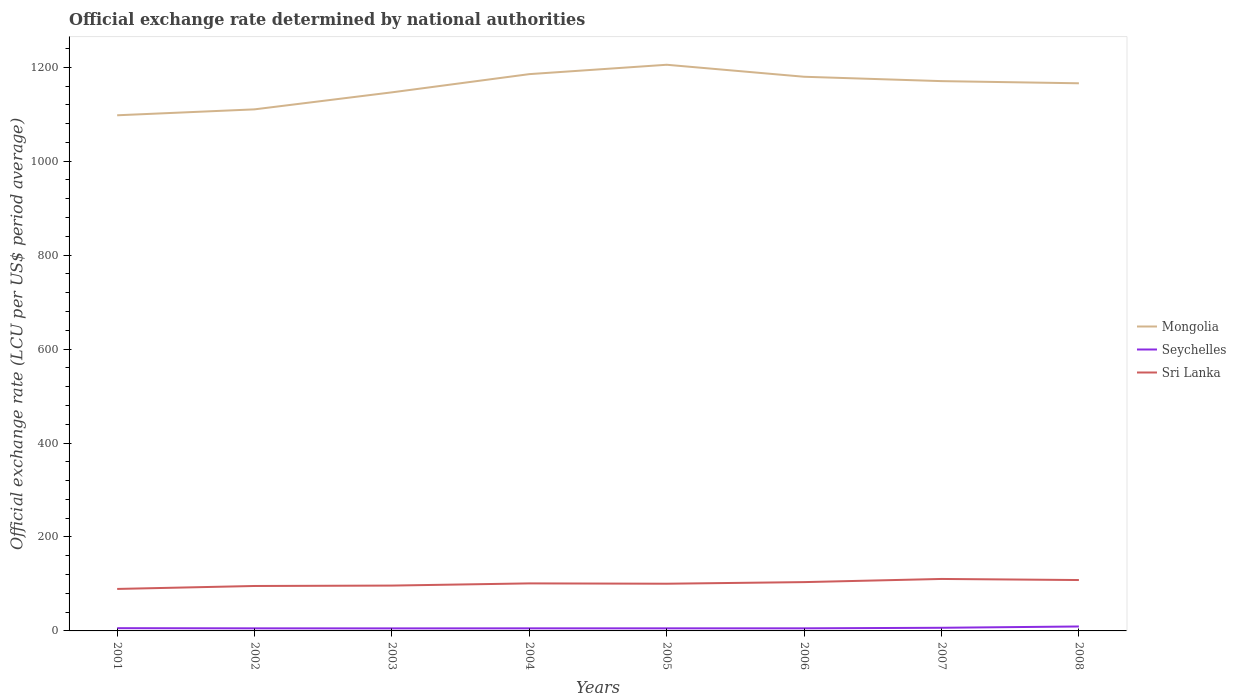How many different coloured lines are there?
Give a very brief answer. 3. Across all years, what is the maximum official exchange rate in Seychelles?
Offer a very short reply. 5.4. In which year was the official exchange rate in Seychelles maximum?
Keep it short and to the point. 2003. What is the total official exchange rate in Seychelles in the graph?
Ensure brevity in your answer.  0.38. What is the difference between the highest and the second highest official exchange rate in Mongolia?
Provide a short and direct response. 107.55. Is the official exchange rate in Seychelles strictly greater than the official exchange rate in Mongolia over the years?
Give a very brief answer. Yes. What is the difference between two consecutive major ticks on the Y-axis?
Provide a succinct answer. 200. Are the values on the major ticks of Y-axis written in scientific E-notation?
Keep it short and to the point. No. Does the graph contain grids?
Your response must be concise. No. Where does the legend appear in the graph?
Your answer should be very brief. Center right. What is the title of the graph?
Offer a very short reply. Official exchange rate determined by national authorities. What is the label or title of the X-axis?
Your response must be concise. Years. What is the label or title of the Y-axis?
Offer a very short reply. Official exchange rate (LCU per US$ period average). What is the Official exchange rate (LCU per US$ period average) of Mongolia in 2001?
Give a very brief answer. 1097.7. What is the Official exchange rate (LCU per US$ period average) of Seychelles in 2001?
Provide a short and direct response. 5.86. What is the Official exchange rate (LCU per US$ period average) in Sri Lanka in 2001?
Keep it short and to the point. 89.38. What is the Official exchange rate (LCU per US$ period average) in Mongolia in 2002?
Your response must be concise. 1110.31. What is the Official exchange rate (LCU per US$ period average) in Seychelles in 2002?
Provide a succinct answer. 5.48. What is the Official exchange rate (LCU per US$ period average) in Sri Lanka in 2002?
Provide a short and direct response. 95.66. What is the Official exchange rate (LCU per US$ period average) of Mongolia in 2003?
Offer a terse response. 1146.54. What is the Official exchange rate (LCU per US$ period average) of Seychelles in 2003?
Your response must be concise. 5.4. What is the Official exchange rate (LCU per US$ period average) in Sri Lanka in 2003?
Offer a terse response. 96.52. What is the Official exchange rate (LCU per US$ period average) of Mongolia in 2004?
Provide a succinct answer. 1185.3. What is the Official exchange rate (LCU per US$ period average) of Sri Lanka in 2004?
Provide a short and direct response. 101.19. What is the Official exchange rate (LCU per US$ period average) in Mongolia in 2005?
Your response must be concise. 1205.25. What is the Official exchange rate (LCU per US$ period average) of Sri Lanka in 2005?
Ensure brevity in your answer.  100.5. What is the Official exchange rate (LCU per US$ period average) in Mongolia in 2006?
Your answer should be very brief. 1179.7. What is the Official exchange rate (LCU per US$ period average) in Seychelles in 2006?
Offer a very short reply. 5.52. What is the Official exchange rate (LCU per US$ period average) in Sri Lanka in 2006?
Make the answer very short. 103.91. What is the Official exchange rate (LCU per US$ period average) of Mongolia in 2007?
Provide a short and direct response. 1170.4. What is the Official exchange rate (LCU per US$ period average) in Seychelles in 2007?
Keep it short and to the point. 6.7. What is the Official exchange rate (LCU per US$ period average) of Sri Lanka in 2007?
Offer a terse response. 110.62. What is the Official exchange rate (LCU per US$ period average) of Mongolia in 2008?
Offer a very short reply. 1165.8. What is the Official exchange rate (LCU per US$ period average) of Seychelles in 2008?
Your answer should be very brief. 9.46. What is the Official exchange rate (LCU per US$ period average) of Sri Lanka in 2008?
Make the answer very short. 108.33. Across all years, what is the maximum Official exchange rate (LCU per US$ period average) of Mongolia?
Ensure brevity in your answer.  1205.25. Across all years, what is the maximum Official exchange rate (LCU per US$ period average) of Seychelles?
Your answer should be compact. 9.46. Across all years, what is the maximum Official exchange rate (LCU per US$ period average) of Sri Lanka?
Give a very brief answer. 110.62. Across all years, what is the minimum Official exchange rate (LCU per US$ period average) in Mongolia?
Keep it short and to the point. 1097.7. Across all years, what is the minimum Official exchange rate (LCU per US$ period average) of Seychelles?
Provide a short and direct response. 5.4. Across all years, what is the minimum Official exchange rate (LCU per US$ period average) in Sri Lanka?
Your answer should be very brief. 89.38. What is the total Official exchange rate (LCU per US$ period average) in Mongolia in the graph?
Offer a very short reply. 9261. What is the total Official exchange rate (LCU per US$ period average) in Seychelles in the graph?
Your answer should be very brief. 49.42. What is the total Official exchange rate (LCU per US$ period average) of Sri Lanka in the graph?
Make the answer very short. 806.13. What is the difference between the Official exchange rate (LCU per US$ period average) in Mongolia in 2001 and that in 2002?
Keep it short and to the point. -12.61. What is the difference between the Official exchange rate (LCU per US$ period average) in Seychelles in 2001 and that in 2002?
Your response must be concise. 0.38. What is the difference between the Official exchange rate (LCU per US$ period average) in Sri Lanka in 2001 and that in 2002?
Provide a short and direct response. -6.28. What is the difference between the Official exchange rate (LCU per US$ period average) in Mongolia in 2001 and that in 2003?
Your answer should be very brief. -48.84. What is the difference between the Official exchange rate (LCU per US$ period average) in Seychelles in 2001 and that in 2003?
Offer a terse response. 0.46. What is the difference between the Official exchange rate (LCU per US$ period average) in Sri Lanka in 2001 and that in 2003?
Provide a short and direct response. -7.14. What is the difference between the Official exchange rate (LCU per US$ period average) of Mongolia in 2001 and that in 2004?
Provide a succinct answer. -87.6. What is the difference between the Official exchange rate (LCU per US$ period average) in Seychelles in 2001 and that in 2004?
Offer a terse response. 0.36. What is the difference between the Official exchange rate (LCU per US$ period average) in Sri Lanka in 2001 and that in 2004?
Offer a terse response. -11.81. What is the difference between the Official exchange rate (LCU per US$ period average) of Mongolia in 2001 and that in 2005?
Your answer should be very brief. -107.55. What is the difference between the Official exchange rate (LCU per US$ period average) in Seychelles in 2001 and that in 2005?
Ensure brevity in your answer.  0.36. What is the difference between the Official exchange rate (LCU per US$ period average) in Sri Lanka in 2001 and that in 2005?
Offer a very short reply. -11.12. What is the difference between the Official exchange rate (LCU per US$ period average) of Mongolia in 2001 and that in 2006?
Keep it short and to the point. -82. What is the difference between the Official exchange rate (LCU per US$ period average) of Seychelles in 2001 and that in 2006?
Offer a very short reply. 0.34. What is the difference between the Official exchange rate (LCU per US$ period average) in Sri Lanka in 2001 and that in 2006?
Offer a terse response. -14.53. What is the difference between the Official exchange rate (LCU per US$ period average) of Mongolia in 2001 and that in 2007?
Provide a succinct answer. -72.7. What is the difference between the Official exchange rate (LCU per US$ period average) in Seychelles in 2001 and that in 2007?
Your response must be concise. -0.84. What is the difference between the Official exchange rate (LCU per US$ period average) of Sri Lanka in 2001 and that in 2007?
Offer a terse response. -21.24. What is the difference between the Official exchange rate (LCU per US$ period average) of Mongolia in 2001 and that in 2008?
Ensure brevity in your answer.  -68.11. What is the difference between the Official exchange rate (LCU per US$ period average) in Seychelles in 2001 and that in 2008?
Offer a terse response. -3.6. What is the difference between the Official exchange rate (LCU per US$ period average) in Sri Lanka in 2001 and that in 2008?
Your response must be concise. -18.95. What is the difference between the Official exchange rate (LCU per US$ period average) of Mongolia in 2002 and that in 2003?
Provide a succinct answer. -36.23. What is the difference between the Official exchange rate (LCU per US$ period average) in Seychelles in 2002 and that in 2003?
Provide a succinct answer. 0.08. What is the difference between the Official exchange rate (LCU per US$ period average) in Sri Lanka in 2002 and that in 2003?
Ensure brevity in your answer.  -0.86. What is the difference between the Official exchange rate (LCU per US$ period average) of Mongolia in 2002 and that in 2004?
Offer a terse response. -74.99. What is the difference between the Official exchange rate (LCU per US$ period average) in Seychelles in 2002 and that in 2004?
Provide a succinct answer. -0.02. What is the difference between the Official exchange rate (LCU per US$ period average) of Sri Lanka in 2002 and that in 2004?
Your answer should be compact. -5.53. What is the difference between the Official exchange rate (LCU per US$ period average) in Mongolia in 2002 and that in 2005?
Ensure brevity in your answer.  -94.94. What is the difference between the Official exchange rate (LCU per US$ period average) in Seychelles in 2002 and that in 2005?
Offer a very short reply. -0.02. What is the difference between the Official exchange rate (LCU per US$ period average) of Sri Lanka in 2002 and that in 2005?
Offer a very short reply. -4.84. What is the difference between the Official exchange rate (LCU per US$ period average) in Mongolia in 2002 and that in 2006?
Your answer should be compact. -69.39. What is the difference between the Official exchange rate (LCU per US$ period average) of Seychelles in 2002 and that in 2006?
Ensure brevity in your answer.  -0.04. What is the difference between the Official exchange rate (LCU per US$ period average) of Sri Lanka in 2002 and that in 2006?
Keep it short and to the point. -8.25. What is the difference between the Official exchange rate (LCU per US$ period average) in Mongolia in 2002 and that in 2007?
Give a very brief answer. -60.09. What is the difference between the Official exchange rate (LCU per US$ period average) in Seychelles in 2002 and that in 2007?
Make the answer very short. -1.22. What is the difference between the Official exchange rate (LCU per US$ period average) in Sri Lanka in 2002 and that in 2007?
Give a very brief answer. -14.96. What is the difference between the Official exchange rate (LCU per US$ period average) of Mongolia in 2002 and that in 2008?
Provide a short and direct response. -55.49. What is the difference between the Official exchange rate (LCU per US$ period average) in Seychelles in 2002 and that in 2008?
Ensure brevity in your answer.  -3.98. What is the difference between the Official exchange rate (LCU per US$ period average) in Sri Lanka in 2002 and that in 2008?
Make the answer very short. -12.67. What is the difference between the Official exchange rate (LCU per US$ period average) of Mongolia in 2003 and that in 2004?
Your response must be concise. -38.76. What is the difference between the Official exchange rate (LCU per US$ period average) of Seychelles in 2003 and that in 2004?
Give a very brief answer. -0.1. What is the difference between the Official exchange rate (LCU per US$ period average) in Sri Lanka in 2003 and that in 2004?
Offer a very short reply. -4.67. What is the difference between the Official exchange rate (LCU per US$ period average) of Mongolia in 2003 and that in 2005?
Provide a short and direct response. -58.7. What is the difference between the Official exchange rate (LCU per US$ period average) of Seychelles in 2003 and that in 2005?
Your answer should be compact. -0.1. What is the difference between the Official exchange rate (LCU per US$ period average) in Sri Lanka in 2003 and that in 2005?
Your answer should be compact. -3.98. What is the difference between the Official exchange rate (LCU per US$ period average) in Mongolia in 2003 and that in 2006?
Make the answer very short. -33.16. What is the difference between the Official exchange rate (LCU per US$ period average) of Seychelles in 2003 and that in 2006?
Your response must be concise. -0.12. What is the difference between the Official exchange rate (LCU per US$ period average) of Sri Lanka in 2003 and that in 2006?
Your response must be concise. -7.39. What is the difference between the Official exchange rate (LCU per US$ period average) in Mongolia in 2003 and that in 2007?
Your response must be concise. -23.86. What is the difference between the Official exchange rate (LCU per US$ period average) of Seychelles in 2003 and that in 2007?
Your response must be concise. -1.3. What is the difference between the Official exchange rate (LCU per US$ period average) of Sri Lanka in 2003 and that in 2007?
Keep it short and to the point. -14.1. What is the difference between the Official exchange rate (LCU per US$ period average) in Mongolia in 2003 and that in 2008?
Offer a terse response. -19.26. What is the difference between the Official exchange rate (LCU per US$ period average) of Seychelles in 2003 and that in 2008?
Offer a terse response. -4.06. What is the difference between the Official exchange rate (LCU per US$ period average) of Sri Lanka in 2003 and that in 2008?
Offer a very short reply. -11.81. What is the difference between the Official exchange rate (LCU per US$ period average) of Mongolia in 2004 and that in 2005?
Offer a very short reply. -19.95. What is the difference between the Official exchange rate (LCU per US$ period average) of Seychelles in 2004 and that in 2005?
Provide a short and direct response. 0. What is the difference between the Official exchange rate (LCU per US$ period average) of Sri Lanka in 2004 and that in 2005?
Your response must be concise. 0.7. What is the difference between the Official exchange rate (LCU per US$ period average) of Mongolia in 2004 and that in 2006?
Provide a short and direct response. 5.6. What is the difference between the Official exchange rate (LCU per US$ period average) in Seychelles in 2004 and that in 2006?
Make the answer very short. -0.02. What is the difference between the Official exchange rate (LCU per US$ period average) of Sri Lanka in 2004 and that in 2006?
Your response must be concise. -2.72. What is the difference between the Official exchange rate (LCU per US$ period average) in Mongolia in 2004 and that in 2007?
Offer a terse response. 14.9. What is the difference between the Official exchange rate (LCU per US$ period average) of Seychelles in 2004 and that in 2007?
Ensure brevity in your answer.  -1.2. What is the difference between the Official exchange rate (LCU per US$ period average) of Sri Lanka in 2004 and that in 2007?
Make the answer very short. -9.43. What is the difference between the Official exchange rate (LCU per US$ period average) of Mongolia in 2004 and that in 2008?
Make the answer very short. 19.49. What is the difference between the Official exchange rate (LCU per US$ period average) in Seychelles in 2004 and that in 2008?
Offer a terse response. -3.96. What is the difference between the Official exchange rate (LCU per US$ period average) in Sri Lanka in 2004 and that in 2008?
Offer a terse response. -7.14. What is the difference between the Official exchange rate (LCU per US$ period average) of Mongolia in 2005 and that in 2006?
Make the answer very short. 25.55. What is the difference between the Official exchange rate (LCU per US$ period average) of Seychelles in 2005 and that in 2006?
Your response must be concise. -0.02. What is the difference between the Official exchange rate (LCU per US$ period average) of Sri Lanka in 2005 and that in 2006?
Keep it short and to the point. -3.42. What is the difference between the Official exchange rate (LCU per US$ period average) in Mongolia in 2005 and that in 2007?
Your answer should be compact. 34.85. What is the difference between the Official exchange rate (LCU per US$ period average) of Seychelles in 2005 and that in 2007?
Offer a very short reply. -1.2. What is the difference between the Official exchange rate (LCU per US$ period average) of Sri Lanka in 2005 and that in 2007?
Provide a short and direct response. -10.13. What is the difference between the Official exchange rate (LCU per US$ period average) of Mongolia in 2005 and that in 2008?
Offer a very short reply. 39.44. What is the difference between the Official exchange rate (LCU per US$ period average) of Seychelles in 2005 and that in 2008?
Provide a succinct answer. -3.96. What is the difference between the Official exchange rate (LCU per US$ period average) in Sri Lanka in 2005 and that in 2008?
Offer a terse response. -7.84. What is the difference between the Official exchange rate (LCU per US$ period average) in Mongolia in 2006 and that in 2007?
Give a very brief answer. 9.3. What is the difference between the Official exchange rate (LCU per US$ period average) of Seychelles in 2006 and that in 2007?
Your response must be concise. -1.18. What is the difference between the Official exchange rate (LCU per US$ period average) of Sri Lanka in 2006 and that in 2007?
Make the answer very short. -6.71. What is the difference between the Official exchange rate (LCU per US$ period average) of Mongolia in 2006 and that in 2008?
Provide a succinct answer. 13.89. What is the difference between the Official exchange rate (LCU per US$ period average) of Seychelles in 2006 and that in 2008?
Ensure brevity in your answer.  -3.94. What is the difference between the Official exchange rate (LCU per US$ period average) in Sri Lanka in 2006 and that in 2008?
Give a very brief answer. -4.42. What is the difference between the Official exchange rate (LCU per US$ period average) of Mongolia in 2007 and that in 2008?
Provide a short and direct response. 4.6. What is the difference between the Official exchange rate (LCU per US$ period average) of Seychelles in 2007 and that in 2008?
Give a very brief answer. -2.76. What is the difference between the Official exchange rate (LCU per US$ period average) of Sri Lanka in 2007 and that in 2008?
Give a very brief answer. 2.29. What is the difference between the Official exchange rate (LCU per US$ period average) in Mongolia in 2001 and the Official exchange rate (LCU per US$ period average) in Seychelles in 2002?
Make the answer very short. 1092.22. What is the difference between the Official exchange rate (LCU per US$ period average) in Mongolia in 2001 and the Official exchange rate (LCU per US$ period average) in Sri Lanka in 2002?
Your response must be concise. 1002.04. What is the difference between the Official exchange rate (LCU per US$ period average) in Seychelles in 2001 and the Official exchange rate (LCU per US$ period average) in Sri Lanka in 2002?
Your answer should be compact. -89.8. What is the difference between the Official exchange rate (LCU per US$ period average) of Mongolia in 2001 and the Official exchange rate (LCU per US$ period average) of Seychelles in 2003?
Offer a terse response. 1092.3. What is the difference between the Official exchange rate (LCU per US$ period average) of Mongolia in 2001 and the Official exchange rate (LCU per US$ period average) of Sri Lanka in 2003?
Offer a terse response. 1001.18. What is the difference between the Official exchange rate (LCU per US$ period average) in Seychelles in 2001 and the Official exchange rate (LCU per US$ period average) in Sri Lanka in 2003?
Provide a succinct answer. -90.66. What is the difference between the Official exchange rate (LCU per US$ period average) of Mongolia in 2001 and the Official exchange rate (LCU per US$ period average) of Seychelles in 2004?
Offer a terse response. 1092.2. What is the difference between the Official exchange rate (LCU per US$ period average) in Mongolia in 2001 and the Official exchange rate (LCU per US$ period average) in Sri Lanka in 2004?
Give a very brief answer. 996.5. What is the difference between the Official exchange rate (LCU per US$ period average) of Seychelles in 2001 and the Official exchange rate (LCU per US$ period average) of Sri Lanka in 2004?
Keep it short and to the point. -95.34. What is the difference between the Official exchange rate (LCU per US$ period average) of Mongolia in 2001 and the Official exchange rate (LCU per US$ period average) of Seychelles in 2005?
Your answer should be very brief. 1092.2. What is the difference between the Official exchange rate (LCU per US$ period average) of Mongolia in 2001 and the Official exchange rate (LCU per US$ period average) of Sri Lanka in 2005?
Offer a terse response. 997.2. What is the difference between the Official exchange rate (LCU per US$ period average) of Seychelles in 2001 and the Official exchange rate (LCU per US$ period average) of Sri Lanka in 2005?
Your answer should be very brief. -94.64. What is the difference between the Official exchange rate (LCU per US$ period average) of Mongolia in 2001 and the Official exchange rate (LCU per US$ period average) of Seychelles in 2006?
Give a very brief answer. 1092.18. What is the difference between the Official exchange rate (LCU per US$ period average) of Mongolia in 2001 and the Official exchange rate (LCU per US$ period average) of Sri Lanka in 2006?
Your answer should be very brief. 993.78. What is the difference between the Official exchange rate (LCU per US$ period average) of Seychelles in 2001 and the Official exchange rate (LCU per US$ period average) of Sri Lanka in 2006?
Ensure brevity in your answer.  -98.06. What is the difference between the Official exchange rate (LCU per US$ period average) in Mongolia in 2001 and the Official exchange rate (LCU per US$ period average) in Seychelles in 2007?
Provide a succinct answer. 1091. What is the difference between the Official exchange rate (LCU per US$ period average) in Mongolia in 2001 and the Official exchange rate (LCU per US$ period average) in Sri Lanka in 2007?
Provide a succinct answer. 987.07. What is the difference between the Official exchange rate (LCU per US$ period average) of Seychelles in 2001 and the Official exchange rate (LCU per US$ period average) of Sri Lanka in 2007?
Make the answer very short. -104.77. What is the difference between the Official exchange rate (LCU per US$ period average) of Mongolia in 2001 and the Official exchange rate (LCU per US$ period average) of Seychelles in 2008?
Ensure brevity in your answer.  1088.24. What is the difference between the Official exchange rate (LCU per US$ period average) of Mongolia in 2001 and the Official exchange rate (LCU per US$ period average) of Sri Lanka in 2008?
Offer a terse response. 989.36. What is the difference between the Official exchange rate (LCU per US$ period average) in Seychelles in 2001 and the Official exchange rate (LCU per US$ period average) in Sri Lanka in 2008?
Offer a terse response. -102.48. What is the difference between the Official exchange rate (LCU per US$ period average) in Mongolia in 2002 and the Official exchange rate (LCU per US$ period average) in Seychelles in 2003?
Offer a very short reply. 1104.91. What is the difference between the Official exchange rate (LCU per US$ period average) in Mongolia in 2002 and the Official exchange rate (LCU per US$ period average) in Sri Lanka in 2003?
Your answer should be compact. 1013.79. What is the difference between the Official exchange rate (LCU per US$ period average) of Seychelles in 2002 and the Official exchange rate (LCU per US$ period average) of Sri Lanka in 2003?
Provide a short and direct response. -91.04. What is the difference between the Official exchange rate (LCU per US$ period average) in Mongolia in 2002 and the Official exchange rate (LCU per US$ period average) in Seychelles in 2004?
Provide a succinct answer. 1104.81. What is the difference between the Official exchange rate (LCU per US$ period average) of Mongolia in 2002 and the Official exchange rate (LCU per US$ period average) of Sri Lanka in 2004?
Give a very brief answer. 1009.12. What is the difference between the Official exchange rate (LCU per US$ period average) in Seychelles in 2002 and the Official exchange rate (LCU per US$ period average) in Sri Lanka in 2004?
Your response must be concise. -95.71. What is the difference between the Official exchange rate (LCU per US$ period average) in Mongolia in 2002 and the Official exchange rate (LCU per US$ period average) in Seychelles in 2005?
Your response must be concise. 1104.81. What is the difference between the Official exchange rate (LCU per US$ period average) of Mongolia in 2002 and the Official exchange rate (LCU per US$ period average) of Sri Lanka in 2005?
Your answer should be very brief. 1009.81. What is the difference between the Official exchange rate (LCU per US$ period average) in Seychelles in 2002 and the Official exchange rate (LCU per US$ period average) in Sri Lanka in 2005?
Ensure brevity in your answer.  -95.02. What is the difference between the Official exchange rate (LCU per US$ period average) in Mongolia in 2002 and the Official exchange rate (LCU per US$ period average) in Seychelles in 2006?
Make the answer very short. 1104.79. What is the difference between the Official exchange rate (LCU per US$ period average) of Mongolia in 2002 and the Official exchange rate (LCU per US$ period average) of Sri Lanka in 2006?
Provide a succinct answer. 1006.4. What is the difference between the Official exchange rate (LCU per US$ period average) in Seychelles in 2002 and the Official exchange rate (LCU per US$ period average) in Sri Lanka in 2006?
Your answer should be compact. -98.43. What is the difference between the Official exchange rate (LCU per US$ period average) in Mongolia in 2002 and the Official exchange rate (LCU per US$ period average) in Seychelles in 2007?
Your answer should be compact. 1103.61. What is the difference between the Official exchange rate (LCU per US$ period average) of Mongolia in 2002 and the Official exchange rate (LCU per US$ period average) of Sri Lanka in 2007?
Your response must be concise. 999.69. What is the difference between the Official exchange rate (LCU per US$ period average) of Seychelles in 2002 and the Official exchange rate (LCU per US$ period average) of Sri Lanka in 2007?
Offer a very short reply. -105.14. What is the difference between the Official exchange rate (LCU per US$ period average) of Mongolia in 2002 and the Official exchange rate (LCU per US$ period average) of Seychelles in 2008?
Provide a short and direct response. 1100.85. What is the difference between the Official exchange rate (LCU per US$ period average) of Mongolia in 2002 and the Official exchange rate (LCU per US$ period average) of Sri Lanka in 2008?
Keep it short and to the point. 1001.98. What is the difference between the Official exchange rate (LCU per US$ period average) of Seychelles in 2002 and the Official exchange rate (LCU per US$ period average) of Sri Lanka in 2008?
Your answer should be compact. -102.85. What is the difference between the Official exchange rate (LCU per US$ period average) in Mongolia in 2003 and the Official exchange rate (LCU per US$ period average) in Seychelles in 2004?
Your answer should be very brief. 1141.04. What is the difference between the Official exchange rate (LCU per US$ period average) in Mongolia in 2003 and the Official exchange rate (LCU per US$ period average) in Sri Lanka in 2004?
Ensure brevity in your answer.  1045.35. What is the difference between the Official exchange rate (LCU per US$ period average) of Seychelles in 2003 and the Official exchange rate (LCU per US$ period average) of Sri Lanka in 2004?
Ensure brevity in your answer.  -95.79. What is the difference between the Official exchange rate (LCU per US$ period average) in Mongolia in 2003 and the Official exchange rate (LCU per US$ period average) in Seychelles in 2005?
Your answer should be compact. 1141.04. What is the difference between the Official exchange rate (LCU per US$ period average) in Mongolia in 2003 and the Official exchange rate (LCU per US$ period average) in Sri Lanka in 2005?
Keep it short and to the point. 1046.04. What is the difference between the Official exchange rate (LCU per US$ period average) in Seychelles in 2003 and the Official exchange rate (LCU per US$ period average) in Sri Lanka in 2005?
Offer a terse response. -95.1. What is the difference between the Official exchange rate (LCU per US$ period average) in Mongolia in 2003 and the Official exchange rate (LCU per US$ period average) in Seychelles in 2006?
Ensure brevity in your answer.  1141.02. What is the difference between the Official exchange rate (LCU per US$ period average) in Mongolia in 2003 and the Official exchange rate (LCU per US$ period average) in Sri Lanka in 2006?
Keep it short and to the point. 1042.63. What is the difference between the Official exchange rate (LCU per US$ period average) of Seychelles in 2003 and the Official exchange rate (LCU per US$ period average) of Sri Lanka in 2006?
Your answer should be compact. -98.51. What is the difference between the Official exchange rate (LCU per US$ period average) in Mongolia in 2003 and the Official exchange rate (LCU per US$ period average) in Seychelles in 2007?
Provide a short and direct response. 1139.84. What is the difference between the Official exchange rate (LCU per US$ period average) of Mongolia in 2003 and the Official exchange rate (LCU per US$ period average) of Sri Lanka in 2007?
Your answer should be compact. 1035.92. What is the difference between the Official exchange rate (LCU per US$ period average) of Seychelles in 2003 and the Official exchange rate (LCU per US$ period average) of Sri Lanka in 2007?
Provide a succinct answer. -105.22. What is the difference between the Official exchange rate (LCU per US$ period average) of Mongolia in 2003 and the Official exchange rate (LCU per US$ period average) of Seychelles in 2008?
Make the answer very short. 1137.09. What is the difference between the Official exchange rate (LCU per US$ period average) in Mongolia in 2003 and the Official exchange rate (LCU per US$ period average) in Sri Lanka in 2008?
Offer a terse response. 1038.21. What is the difference between the Official exchange rate (LCU per US$ period average) in Seychelles in 2003 and the Official exchange rate (LCU per US$ period average) in Sri Lanka in 2008?
Offer a very short reply. -102.93. What is the difference between the Official exchange rate (LCU per US$ period average) of Mongolia in 2004 and the Official exchange rate (LCU per US$ period average) of Seychelles in 2005?
Offer a terse response. 1179.8. What is the difference between the Official exchange rate (LCU per US$ period average) in Mongolia in 2004 and the Official exchange rate (LCU per US$ period average) in Sri Lanka in 2005?
Offer a very short reply. 1084.8. What is the difference between the Official exchange rate (LCU per US$ period average) in Seychelles in 2004 and the Official exchange rate (LCU per US$ period average) in Sri Lanka in 2005?
Provide a short and direct response. -95. What is the difference between the Official exchange rate (LCU per US$ period average) of Mongolia in 2004 and the Official exchange rate (LCU per US$ period average) of Seychelles in 2006?
Your answer should be very brief. 1179.78. What is the difference between the Official exchange rate (LCU per US$ period average) of Mongolia in 2004 and the Official exchange rate (LCU per US$ period average) of Sri Lanka in 2006?
Provide a succinct answer. 1081.38. What is the difference between the Official exchange rate (LCU per US$ period average) of Seychelles in 2004 and the Official exchange rate (LCU per US$ period average) of Sri Lanka in 2006?
Keep it short and to the point. -98.41. What is the difference between the Official exchange rate (LCU per US$ period average) in Mongolia in 2004 and the Official exchange rate (LCU per US$ period average) in Seychelles in 2007?
Ensure brevity in your answer.  1178.6. What is the difference between the Official exchange rate (LCU per US$ period average) of Mongolia in 2004 and the Official exchange rate (LCU per US$ period average) of Sri Lanka in 2007?
Offer a terse response. 1074.67. What is the difference between the Official exchange rate (LCU per US$ period average) of Seychelles in 2004 and the Official exchange rate (LCU per US$ period average) of Sri Lanka in 2007?
Keep it short and to the point. -105.12. What is the difference between the Official exchange rate (LCU per US$ period average) in Mongolia in 2004 and the Official exchange rate (LCU per US$ period average) in Seychelles in 2008?
Provide a succinct answer. 1175.84. What is the difference between the Official exchange rate (LCU per US$ period average) in Mongolia in 2004 and the Official exchange rate (LCU per US$ period average) in Sri Lanka in 2008?
Give a very brief answer. 1076.96. What is the difference between the Official exchange rate (LCU per US$ period average) in Seychelles in 2004 and the Official exchange rate (LCU per US$ period average) in Sri Lanka in 2008?
Ensure brevity in your answer.  -102.83. What is the difference between the Official exchange rate (LCU per US$ period average) in Mongolia in 2005 and the Official exchange rate (LCU per US$ period average) in Seychelles in 2006?
Your response must be concise. 1199.73. What is the difference between the Official exchange rate (LCU per US$ period average) in Mongolia in 2005 and the Official exchange rate (LCU per US$ period average) in Sri Lanka in 2006?
Provide a succinct answer. 1101.33. What is the difference between the Official exchange rate (LCU per US$ period average) in Seychelles in 2005 and the Official exchange rate (LCU per US$ period average) in Sri Lanka in 2006?
Your response must be concise. -98.41. What is the difference between the Official exchange rate (LCU per US$ period average) of Mongolia in 2005 and the Official exchange rate (LCU per US$ period average) of Seychelles in 2007?
Give a very brief answer. 1198.55. What is the difference between the Official exchange rate (LCU per US$ period average) of Mongolia in 2005 and the Official exchange rate (LCU per US$ period average) of Sri Lanka in 2007?
Provide a succinct answer. 1094.62. What is the difference between the Official exchange rate (LCU per US$ period average) in Seychelles in 2005 and the Official exchange rate (LCU per US$ period average) in Sri Lanka in 2007?
Ensure brevity in your answer.  -105.12. What is the difference between the Official exchange rate (LCU per US$ period average) in Mongolia in 2005 and the Official exchange rate (LCU per US$ period average) in Seychelles in 2008?
Provide a succinct answer. 1195.79. What is the difference between the Official exchange rate (LCU per US$ period average) of Mongolia in 2005 and the Official exchange rate (LCU per US$ period average) of Sri Lanka in 2008?
Offer a terse response. 1096.91. What is the difference between the Official exchange rate (LCU per US$ period average) of Seychelles in 2005 and the Official exchange rate (LCU per US$ period average) of Sri Lanka in 2008?
Provide a short and direct response. -102.83. What is the difference between the Official exchange rate (LCU per US$ period average) in Mongolia in 2006 and the Official exchange rate (LCU per US$ period average) in Seychelles in 2007?
Keep it short and to the point. 1173. What is the difference between the Official exchange rate (LCU per US$ period average) of Mongolia in 2006 and the Official exchange rate (LCU per US$ period average) of Sri Lanka in 2007?
Offer a very short reply. 1069.08. What is the difference between the Official exchange rate (LCU per US$ period average) in Seychelles in 2006 and the Official exchange rate (LCU per US$ period average) in Sri Lanka in 2007?
Give a very brief answer. -105.1. What is the difference between the Official exchange rate (LCU per US$ period average) in Mongolia in 2006 and the Official exchange rate (LCU per US$ period average) in Seychelles in 2008?
Your answer should be very brief. 1170.24. What is the difference between the Official exchange rate (LCU per US$ period average) of Mongolia in 2006 and the Official exchange rate (LCU per US$ period average) of Sri Lanka in 2008?
Keep it short and to the point. 1071.37. What is the difference between the Official exchange rate (LCU per US$ period average) of Seychelles in 2006 and the Official exchange rate (LCU per US$ period average) of Sri Lanka in 2008?
Your answer should be compact. -102.81. What is the difference between the Official exchange rate (LCU per US$ period average) of Mongolia in 2007 and the Official exchange rate (LCU per US$ period average) of Seychelles in 2008?
Offer a very short reply. 1160.94. What is the difference between the Official exchange rate (LCU per US$ period average) of Mongolia in 2007 and the Official exchange rate (LCU per US$ period average) of Sri Lanka in 2008?
Offer a terse response. 1062.07. What is the difference between the Official exchange rate (LCU per US$ period average) of Seychelles in 2007 and the Official exchange rate (LCU per US$ period average) of Sri Lanka in 2008?
Provide a succinct answer. -101.63. What is the average Official exchange rate (LCU per US$ period average) of Mongolia per year?
Offer a terse response. 1157.62. What is the average Official exchange rate (LCU per US$ period average) in Seychelles per year?
Offer a very short reply. 6.18. What is the average Official exchange rate (LCU per US$ period average) in Sri Lanka per year?
Offer a very short reply. 100.77. In the year 2001, what is the difference between the Official exchange rate (LCU per US$ period average) in Mongolia and Official exchange rate (LCU per US$ period average) in Seychelles?
Your answer should be compact. 1091.84. In the year 2001, what is the difference between the Official exchange rate (LCU per US$ period average) of Mongolia and Official exchange rate (LCU per US$ period average) of Sri Lanka?
Ensure brevity in your answer.  1008.31. In the year 2001, what is the difference between the Official exchange rate (LCU per US$ period average) of Seychelles and Official exchange rate (LCU per US$ period average) of Sri Lanka?
Offer a very short reply. -83.53. In the year 2002, what is the difference between the Official exchange rate (LCU per US$ period average) in Mongolia and Official exchange rate (LCU per US$ period average) in Seychelles?
Your response must be concise. 1104.83. In the year 2002, what is the difference between the Official exchange rate (LCU per US$ period average) of Mongolia and Official exchange rate (LCU per US$ period average) of Sri Lanka?
Keep it short and to the point. 1014.65. In the year 2002, what is the difference between the Official exchange rate (LCU per US$ period average) of Seychelles and Official exchange rate (LCU per US$ period average) of Sri Lanka?
Give a very brief answer. -90.18. In the year 2003, what is the difference between the Official exchange rate (LCU per US$ period average) of Mongolia and Official exchange rate (LCU per US$ period average) of Seychelles?
Provide a short and direct response. 1141.14. In the year 2003, what is the difference between the Official exchange rate (LCU per US$ period average) of Mongolia and Official exchange rate (LCU per US$ period average) of Sri Lanka?
Your response must be concise. 1050.02. In the year 2003, what is the difference between the Official exchange rate (LCU per US$ period average) of Seychelles and Official exchange rate (LCU per US$ period average) of Sri Lanka?
Offer a very short reply. -91.12. In the year 2004, what is the difference between the Official exchange rate (LCU per US$ period average) of Mongolia and Official exchange rate (LCU per US$ period average) of Seychelles?
Provide a short and direct response. 1179.8. In the year 2004, what is the difference between the Official exchange rate (LCU per US$ period average) of Mongolia and Official exchange rate (LCU per US$ period average) of Sri Lanka?
Keep it short and to the point. 1084.1. In the year 2004, what is the difference between the Official exchange rate (LCU per US$ period average) in Seychelles and Official exchange rate (LCU per US$ period average) in Sri Lanka?
Your response must be concise. -95.69. In the year 2005, what is the difference between the Official exchange rate (LCU per US$ period average) of Mongolia and Official exchange rate (LCU per US$ period average) of Seychelles?
Your answer should be very brief. 1199.75. In the year 2005, what is the difference between the Official exchange rate (LCU per US$ period average) in Mongolia and Official exchange rate (LCU per US$ period average) in Sri Lanka?
Offer a terse response. 1104.75. In the year 2005, what is the difference between the Official exchange rate (LCU per US$ period average) in Seychelles and Official exchange rate (LCU per US$ period average) in Sri Lanka?
Provide a short and direct response. -95. In the year 2006, what is the difference between the Official exchange rate (LCU per US$ period average) in Mongolia and Official exchange rate (LCU per US$ period average) in Seychelles?
Provide a short and direct response. 1174.18. In the year 2006, what is the difference between the Official exchange rate (LCU per US$ period average) of Mongolia and Official exchange rate (LCU per US$ period average) of Sri Lanka?
Your answer should be very brief. 1075.78. In the year 2006, what is the difference between the Official exchange rate (LCU per US$ period average) in Seychelles and Official exchange rate (LCU per US$ period average) in Sri Lanka?
Provide a succinct answer. -98.39. In the year 2007, what is the difference between the Official exchange rate (LCU per US$ period average) of Mongolia and Official exchange rate (LCU per US$ period average) of Seychelles?
Provide a short and direct response. 1163.7. In the year 2007, what is the difference between the Official exchange rate (LCU per US$ period average) of Mongolia and Official exchange rate (LCU per US$ period average) of Sri Lanka?
Your response must be concise. 1059.78. In the year 2007, what is the difference between the Official exchange rate (LCU per US$ period average) in Seychelles and Official exchange rate (LCU per US$ period average) in Sri Lanka?
Make the answer very short. -103.92. In the year 2008, what is the difference between the Official exchange rate (LCU per US$ period average) in Mongolia and Official exchange rate (LCU per US$ period average) in Seychelles?
Your response must be concise. 1156.35. In the year 2008, what is the difference between the Official exchange rate (LCU per US$ period average) of Mongolia and Official exchange rate (LCU per US$ period average) of Sri Lanka?
Your answer should be compact. 1057.47. In the year 2008, what is the difference between the Official exchange rate (LCU per US$ period average) in Seychelles and Official exchange rate (LCU per US$ period average) in Sri Lanka?
Offer a terse response. -98.88. What is the ratio of the Official exchange rate (LCU per US$ period average) of Seychelles in 2001 to that in 2002?
Provide a succinct answer. 1.07. What is the ratio of the Official exchange rate (LCU per US$ period average) in Sri Lanka in 2001 to that in 2002?
Provide a succinct answer. 0.93. What is the ratio of the Official exchange rate (LCU per US$ period average) in Mongolia in 2001 to that in 2003?
Make the answer very short. 0.96. What is the ratio of the Official exchange rate (LCU per US$ period average) in Seychelles in 2001 to that in 2003?
Ensure brevity in your answer.  1.08. What is the ratio of the Official exchange rate (LCU per US$ period average) in Sri Lanka in 2001 to that in 2003?
Your answer should be compact. 0.93. What is the ratio of the Official exchange rate (LCU per US$ period average) in Mongolia in 2001 to that in 2004?
Provide a succinct answer. 0.93. What is the ratio of the Official exchange rate (LCU per US$ period average) in Seychelles in 2001 to that in 2004?
Offer a terse response. 1.06. What is the ratio of the Official exchange rate (LCU per US$ period average) of Sri Lanka in 2001 to that in 2004?
Offer a terse response. 0.88. What is the ratio of the Official exchange rate (LCU per US$ period average) of Mongolia in 2001 to that in 2005?
Provide a short and direct response. 0.91. What is the ratio of the Official exchange rate (LCU per US$ period average) in Seychelles in 2001 to that in 2005?
Offer a very short reply. 1.06. What is the ratio of the Official exchange rate (LCU per US$ period average) of Sri Lanka in 2001 to that in 2005?
Your answer should be compact. 0.89. What is the ratio of the Official exchange rate (LCU per US$ period average) in Mongolia in 2001 to that in 2006?
Ensure brevity in your answer.  0.93. What is the ratio of the Official exchange rate (LCU per US$ period average) in Seychelles in 2001 to that in 2006?
Ensure brevity in your answer.  1.06. What is the ratio of the Official exchange rate (LCU per US$ period average) of Sri Lanka in 2001 to that in 2006?
Offer a terse response. 0.86. What is the ratio of the Official exchange rate (LCU per US$ period average) of Mongolia in 2001 to that in 2007?
Make the answer very short. 0.94. What is the ratio of the Official exchange rate (LCU per US$ period average) in Seychelles in 2001 to that in 2007?
Give a very brief answer. 0.87. What is the ratio of the Official exchange rate (LCU per US$ period average) of Sri Lanka in 2001 to that in 2007?
Ensure brevity in your answer.  0.81. What is the ratio of the Official exchange rate (LCU per US$ period average) in Mongolia in 2001 to that in 2008?
Your answer should be compact. 0.94. What is the ratio of the Official exchange rate (LCU per US$ period average) of Seychelles in 2001 to that in 2008?
Your response must be concise. 0.62. What is the ratio of the Official exchange rate (LCU per US$ period average) in Sri Lanka in 2001 to that in 2008?
Offer a very short reply. 0.83. What is the ratio of the Official exchange rate (LCU per US$ period average) in Mongolia in 2002 to that in 2003?
Your answer should be compact. 0.97. What is the ratio of the Official exchange rate (LCU per US$ period average) of Seychelles in 2002 to that in 2003?
Make the answer very short. 1.01. What is the ratio of the Official exchange rate (LCU per US$ period average) in Mongolia in 2002 to that in 2004?
Make the answer very short. 0.94. What is the ratio of the Official exchange rate (LCU per US$ period average) of Sri Lanka in 2002 to that in 2004?
Offer a very short reply. 0.95. What is the ratio of the Official exchange rate (LCU per US$ period average) of Mongolia in 2002 to that in 2005?
Give a very brief answer. 0.92. What is the ratio of the Official exchange rate (LCU per US$ period average) in Sri Lanka in 2002 to that in 2005?
Give a very brief answer. 0.95. What is the ratio of the Official exchange rate (LCU per US$ period average) in Mongolia in 2002 to that in 2006?
Make the answer very short. 0.94. What is the ratio of the Official exchange rate (LCU per US$ period average) in Seychelles in 2002 to that in 2006?
Your response must be concise. 0.99. What is the ratio of the Official exchange rate (LCU per US$ period average) of Sri Lanka in 2002 to that in 2006?
Offer a terse response. 0.92. What is the ratio of the Official exchange rate (LCU per US$ period average) in Mongolia in 2002 to that in 2007?
Your answer should be very brief. 0.95. What is the ratio of the Official exchange rate (LCU per US$ period average) of Seychelles in 2002 to that in 2007?
Make the answer very short. 0.82. What is the ratio of the Official exchange rate (LCU per US$ period average) in Sri Lanka in 2002 to that in 2007?
Keep it short and to the point. 0.86. What is the ratio of the Official exchange rate (LCU per US$ period average) in Mongolia in 2002 to that in 2008?
Offer a very short reply. 0.95. What is the ratio of the Official exchange rate (LCU per US$ period average) of Seychelles in 2002 to that in 2008?
Your response must be concise. 0.58. What is the ratio of the Official exchange rate (LCU per US$ period average) in Sri Lanka in 2002 to that in 2008?
Ensure brevity in your answer.  0.88. What is the ratio of the Official exchange rate (LCU per US$ period average) in Mongolia in 2003 to that in 2004?
Offer a very short reply. 0.97. What is the ratio of the Official exchange rate (LCU per US$ period average) of Seychelles in 2003 to that in 2004?
Give a very brief answer. 0.98. What is the ratio of the Official exchange rate (LCU per US$ period average) of Sri Lanka in 2003 to that in 2004?
Offer a terse response. 0.95. What is the ratio of the Official exchange rate (LCU per US$ period average) of Mongolia in 2003 to that in 2005?
Offer a very short reply. 0.95. What is the ratio of the Official exchange rate (LCU per US$ period average) in Seychelles in 2003 to that in 2005?
Give a very brief answer. 0.98. What is the ratio of the Official exchange rate (LCU per US$ period average) in Sri Lanka in 2003 to that in 2005?
Give a very brief answer. 0.96. What is the ratio of the Official exchange rate (LCU per US$ period average) in Mongolia in 2003 to that in 2006?
Offer a terse response. 0.97. What is the ratio of the Official exchange rate (LCU per US$ period average) of Seychelles in 2003 to that in 2006?
Keep it short and to the point. 0.98. What is the ratio of the Official exchange rate (LCU per US$ period average) of Sri Lanka in 2003 to that in 2006?
Give a very brief answer. 0.93. What is the ratio of the Official exchange rate (LCU per US$ period average) in Mongolia in 2003 to that in 2007?
Keep it short and to the point. 0.98. What is the ratio of the Official exchange rate (LCU per US$ period average) of Seychelles in 2003 to that in 2007?
Offer a very short reply. 0.81. What is the ratio of the Official exchange rate (LCU per US$ period average) in Sri Lanka in 2003 to that in 2007?
Offer a very short reply. 0.87. What is the ratio of the Official exchange rate (LCU per US$ period average) in Mongolia in 2003 to that in 2008?
Your response must be concise. 0.98. What is the ratio of the Official exchange rate (LCU per US$ period average) in Seychelles in 2003 to that in 2008?
Keep it short and to the point. 0.57. What is the ratio of the Official exchange rate (LCU per US$ period average) in Sri Lanka in 2003 to that in 2008?
Give a very brief answer. 0.89. What is the ratio of the Official exchange rate (LCU per US$ period average) of Mongolia in 2004 to that in 2005?
Provide a succinct answer. 0.98. What is the ratio of the Official exchange rate (LCU per US$ period average) of Seychelles in 2004 to that in 2005?
Offer a terse response. 1. What is the ratio of the Official exchange rate (LCU per US$ period average) of Sri Lanka in 2004 to that in 2005?
Provide a succinct answer. 1.01. What is the ratio of the Official exchange rate (LCU per US$ period average) of Mongolia in 2004 to that in 2006?
Your response must be concise. 1. What is the ratio of the Official exchange rate (LCU per US$ period average) in Seychelles in 2004 to that in 2006?
Provide a succinct answer. 1. What is the ratio of the Official exchange rate (LCU per US$ period average) in Sri Lanka in 2004 to that in 2006?
Provide a succinct answer. 0.97. What is the ratio of the Official exchange rate (LCU per US$ period average) of Mongolia in 2004 to that in 2007?
Ensure brevity in your answer.  1.01. What is the ratio of the Official exchange rate (LCU per US$ period average) in Seychelles in 2004 to that in 2007?
Ensure brevity in your answer.  0.82. What is the ratio of the Official exchange rate (LCU per US$ period average) of Sri Lanka in 2004 to that in 2007?
Provide a succinct answer. 0.91. What is the ratio of the Official exchange rate (LCU per US$ period average) of Mongolia in 2004 to that in 2008?
Make the answer very short. 1.02. What is the ratio of the Official exchange rate (LCU per US$ period average) in Seychelles in 2004 to that in 2008?
Your response must be concise. 0.58. What is the ratio of the Official exchange rate (LCU per US$ period average) of Sri Lanka in 2004 to that in 2008?
Give a very brief answer. 0.93. What is the ratio of the Official exchange rate (LCU per US$ period average) of Mongolia in 2005 to that in 2006?
Your response must be concise. 1.02. What is the ratio of the Official exchange rate (LCU per US$ period average) of Sri Lanka in 2005 to that in 2006?
Keep it short and to the point. 0.97. What is the ratio of the Official exchange rate (LCU per US$ period average) of Mongolia in 2005 to that in 2007?
Keep it short and to the point. 1.03. What is the ratio of the Official exchange rate (LCU per US$ period average) in Seychelles in 2005 to that in 2007?
Offer a very short reply. 0.82. What is the ratio of the Official exchange rate (LCU per US$ period average) in Sri Lanka in 2005 to that in 2007?
Keep it short and to the point. 0.91. What is the ratio of the Official exchange rate (LCU per US$ period average) of Mongolia in 2005 to that in 2008?
Your response must be concise. 1.03. What is the ratio of the Official exchange rate (LCU per US$ period average) of Seychelles in 2005 to that in 2008?
Provide a succinct answer. 0.58. What is the ratio of the Official exchange rate (LCU per US$ period average) in Sri Lanka in 2005 to that in 2008?
Your response must be concise. 0.93. What is the ratio of the Official exchange rate (LCU per US$ period average) in Mongolia in 2006 to that in 2007?
Your response must be concise. 1.01. What is the ratio of the Official exchange rate (LCU per US$ period average) in Seychelles in 2006 to that in 2007?
Your answer should be very brief. 0.82. What is the ratio of the Official exchange rate (LCU per US$ period average) of Sri Lanka in 2006 to that in 2007?
Provide a short and direct response. 0.94. What is the ratio of the Official exchange rate (LCU per US$ period average) in Mongolia in 2006 to that in 2008?
Give a very brief answer. 1.01. What is the ratio of the Official exchange rate (LCU per US$ period average) of Seychelles in 2006 to that in 2008?
Provide a succinct answer. 0.58. What is the ratio of the Official exchange rate (LCU per US$ period average) of Sri Lanka in 2006 to that in 2008?
Your answer should be very brief. 0.96. What is the ratio of the Official exchange rate (LCU per US$ period average) of Mongolia in 2007 to that in 2008?
Give a very brief answer. 1. What is the ratio of the Official exchange rate (LCU per US$ period average) of Seychelles in 2007 to that in 2008?
Offer a very short reply. 0.71. What is the ratio of the Official exchange rate (LCU per US$ period average) of Sri Lanka in 2007 to that in 2008?
Provide a succinct answer. 1.02. What is the difference between the highest and the second highest Official exchange rate (LCU per US$ period average) of Mongolia?
Ensure brevity in your answer.  19.95. What is the difference between the highest and the second highest Official exchange rate (LCU per US$ period average) of Seychelles?
Your answer should be very brief. 2.76. What is the difference between the highest and the second highest Official exchange rate (LCU per US$ period average) in Sri Lanka?
Your answer should be very brief. 2.29. What is the difference between the highest and the lowest Official exchange rate (LCU per US$ period average) in Mongolia?
Your answer should be compact. 107.55. What is the difference between the highest and the lowest Official exchange rate (LCU per US$ period average) of Seychelles?
Your response must be concise. 4.06. What is the difference between the highest and the lowest Official exchange rate (LCU per US$ period average) of Sri Lanka?
Provide a short and direct response. 21.24. 